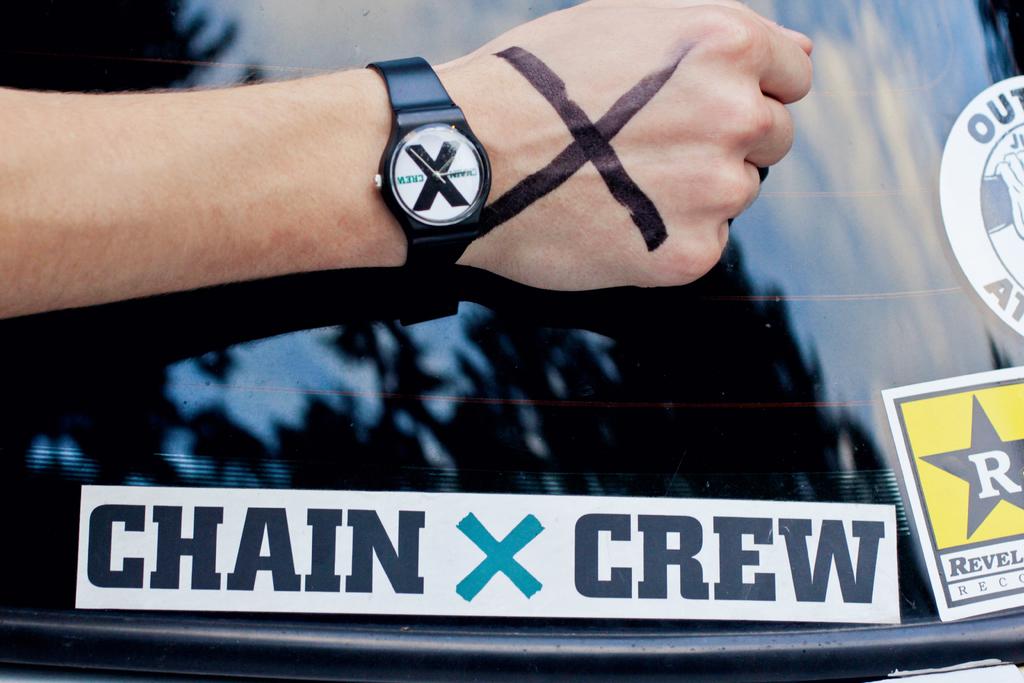What crew is this?
Offer a terse response. Chain crew. What letter is in the star?
Offer a terse response. R. 